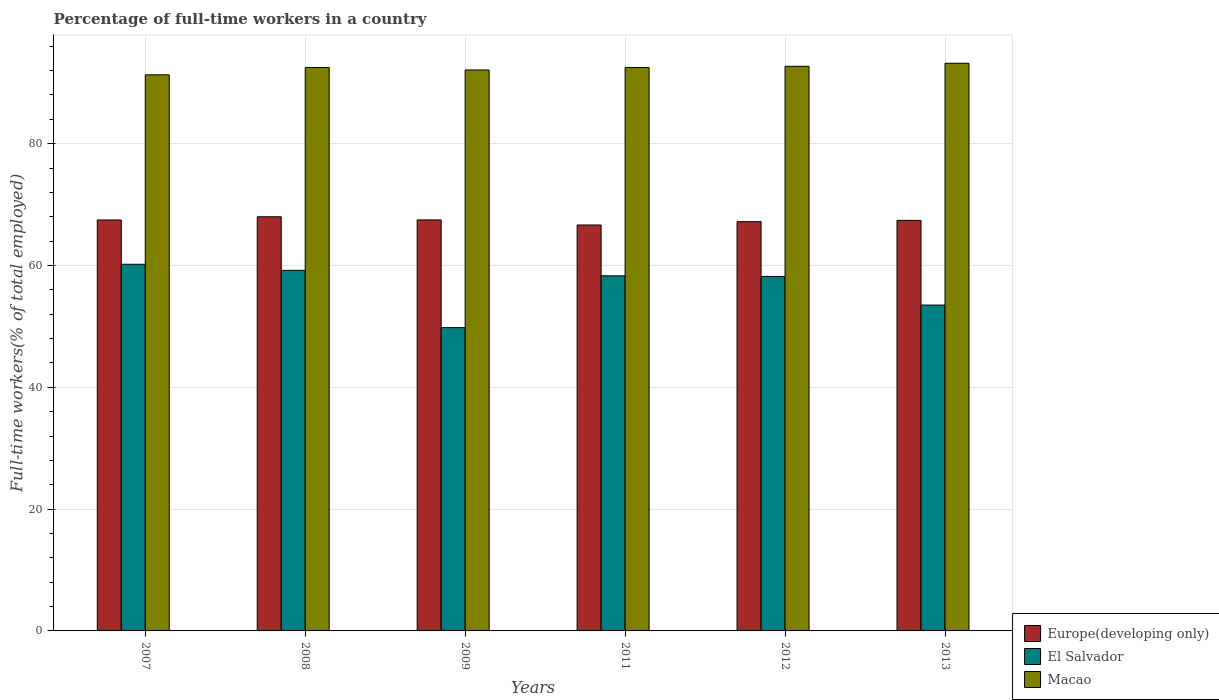How many different coloured bars are there?
Provide a succinct answer. 3. Are the number of bars per tick equal to the number of legend labels?
Ensure brevity in your answer.  Yes. What is the label of the 3rd group of bars from the left?
Give a very brief answer. 2009. What is the percentage of full-time workers in Macao in 2013?
Your answer should be compact. 93.2. Across all years, what is the maximum percentage of full-time workers in Europe(developing only)?
Make the answer very short. 68. Across all years, what is the minimum percentage of full-time workers in Macao?
Provide a succinct answer. 91.3. In which year was the percentage of full-time workers in Macao minimum?
Offer a terse response. 2007. What is the total percentage of full-time workers in El Salvador in the graph?
Make the answer very short. 339.2. What is the difference between the percentage of full-time workers in Europe(developing only) in 2009 and that in 2013?
Give a very brief answer. 0.07. What is the difference between the percentage of full-time workers in Europe(developing only) in 2008 and the percentage of full-time workers in Macao in 2013?
Your answer should be compact. -25.2. What is the average percentage of full-time workers in Macao per year?
Keep it short and to the point. 92.38. In the year 2008, what is the difference between the percentage of full-time workers in Europe(developing only) and percentage of full-time workers in Macao?
Provide a succinct answer. -24.5. In how many years, is the percentage of full-time workers in Macao greater than 56 %?
Offer a very short reply. 6. What is the ratio of the percentage of full-time workers in Macao in 2012 to that in 2013?
Keep it short and to the point. 0.99. Is the percentage of full-time workers in El Salvador in 2008 less than that in 2013?
Provide a short and direct response. No. Is the difference between the percentage of full-time workers in Europe(developing only) in 2007 and 2011 greater than the difference between the percentage of full-time workers in Macao in 2007 and 2011?
Make the answer very short. Yes. What is the difference between the highest and the second highest percentage of full-time workers in Macao?
Provide a succinct answer. 0.5. What is the difference between the highest and the lowest percentage of full-time workers in Macao?
Keep it short and to the point. 1.9. In how many years, is the percentage of full-time workers in El Salvador greater than the average percentage of full-time workers in El Salvador taken over all years?
Provide a succinct answer. 4. Is the sum of the percentage of full-time workers in Europe(developing only) in 2008 and 2011 greater than the maximum percentage of full-time workers in El Salvador across all years?
Your answer should be very brief. Yes. What does the 2nd bar from the left in 2012 represents?
Provide a succinct answer. El Salvador. What does the 3rd bar from the right in 2012 represents?
Provide a short and direct response. Europe(developing only). How many bars are there?
Ensure brevity in your answer.  18. Does the graph contain any zero values?
Provide a short and direct response. No. Does the graph contain grids?
Offer a terse response. Yes. How many legend labels are there?
Provide a succinct answer. 3. What is the title of the graph?
Make the answer very short. Percentage of full-time workers in a country. Does "Arab World" appear as one of the legend labels in the graph?
Keep it short and to the point. No. What is the label or title of the X-axis?
Provide a short and direct response. Years. What is the label or title of the Y-axis?
Make the answer very short. Full-time workers(% of total employed). What is the Full-time workers(% of total employed) of Europe(developing only) in 2007?
Ensure brevity in your answer.  67.47. What is the Full-time workers(% of total employed) of El Salvador in 2007?
Offer a terse response. 60.2. What is the Full-time workers(% of total employed) of Macao in 2007?
Provide a short and direct response. 91.3. What is the Full-time workers(% of total employed) of Europe(developing only) in 2008?
Ensure brevity in your answer.  68. What is the Full-time workers(% of total employed) in El Salvador in 2008?
Offer a very short reply. 59.2. What is the Full-time workers(% of total employed) in Macao in 2008?
Ensure brevity in your answer.  92.5. What is the Full-time workers(% of total employed) of Europe(developing only) in 2009?
Provide a short and direct response. 67.48. What is the Full-time workers(% of total employed) of El Salvador in 2009?
Offer a very short reply. 49.8. What is the Full-time workers(% of total employed) of Macao in 2009?
Your response must be concise. 92.1. What is the Full-time workers(% of total employed) in Europe(developing only) in 2011?
Keep it short and to the point. 66.64. What is the Full-time workers(% of total employed) in El Salvador in 2011?
Offer a very short reply. 58.3. What is the Full-time workers(% of total employed) of Macao in 2011?
Provide a succinct answer. 92.5. What is the Full-time workers(% of total employed) of Europe(developing only) in 2012?
Offer a very short reply. 67.19. What is the Full-time workers(% of total employed) in El Salvador in 2012?
Your answer should be very brief. 58.2. What is the Full-time workers(% of total employed) of Macao in 2012?
Your answer should be compact. 92.7. What is the Full-time workers(% of total employed) of Europe(developing only) in 2013?
Your answer should be very brief. 67.41. What is the Full-time workers(% of total employed) in El Salvador in 2013?
Your answer should be compact. 53.5. What is the Full-time workers(% of total employed) in Macao in 2013?
Provide a succinct answer. 93.2. Across all years, what is the maximum Full-time workers(% of total employed) in Europe(developing only)?
Offer a terse response. 68. Across all years, what is the maximum Full-time workers(% of total employed) in El Salvador?
Your answer should be very brief. 60.2. Across all years, what is the maximum Full-time workers(% of total employed) in Macao?
Keep it short and to the point. 93.2. Across all years, what is the minimum Full-time workers(% of total employed) of Europe(developing only)?
Ensure brevity in your answer.  66.64. Across all years, what is the minimum Full-time workers(% of total employed) in El Salvador?
Provide a short and direct response. 49.8. Across all years, what is the minimum Full-time workers(% of total employed) in Macao?
Keep it short and to the point. 91.3. What is the total Full-time workers(% of total employed) in Europe(developing only) in the graph?
Ensure brevity in your answer.  404.19. What is the total Full-time workers(% of total employed) in El Salvador in the graph?
Keep it short and to the point. 339.2. What is the total Full-time workers(% of total employed) of Macao in the graph?
Offer a terse response. 554.3. What is the difference between the Full-time workers(% of total employed) of Europe(developing only) in 2007 and that in 2008?
Make the answer very short. -0.53. What is the difference between the Full-time workers(% of total employed) in Macao in 2007 and that in 2008?
Your response must be concise. -1.2. What is the difference between the Full-time workers(% of total employed) of Europe(developing only) in 2007 and that in 2009?
Ensure brevity in your answer.  -0.01. What is the difference between the Full-time workers(% of total employed) in El Salvador in 2007 and that in 2009?
Your answer should be compact. 10.4. What is the difference between the Full-time workers(% of total employed) of Europe(developing only) in 2007 and that in 2011?
Provide a succinct answer. 0.83. What is the difference between the Full-time workers(% of total employed) in El Salvador in 2007 and that in 2011?
Make the answer very short. 1.9. What is the difference between the Full-time workers(% of total employed) of Europe(developing only) in 2007 and that in 2012?
Ensure brevity in your answer.  0.28. What is the difference between the Full-time workers(% of total employed) in El Salvador in 2007 and that in 2012?
Provide a short and direct response. 2. What is the difference between the Full-time workers(% of total employed) in Europe(developing only) in 2007 and that in 2013?
Your answer should be very brief. 0.06. What is the difference between the Full-time workers(% of total employed) of Macao in 2007 and that in 2013?
Offer a terse response. -1.9. What is the difference between the Full-time workers(% of total employed) in Europe(developing only) in 2008 and that in 2009?
Your answer should be compact. 0.52. What is the difference between the Full-time workers(% of total employed) in El Salvador in 2008 and that in 2009?
Your response must be concise. 9.4. What is the difference between the Full-time workers(% of total employed) of Europe(developing only) in 2008 and that in 2011?
Your answer should be very brief. 1.35. What is the difference between the Full-time workers(% of total employed) in Macao in 2008 and that in 2011?
Make the answer very short. 0. What is the difference between the Full-time workers(% of total employed) in Europe(developing only) in 2008 and that in 2012?
Offer a very short reply. 0.81. What is the difference between the Full-time workers(% of total employed) in Europe(developing only) in 2008 and that in 2013?
Offer a very short reply. 0.59. What is the difference between the Full-time workers(% of total employed) in El Salvador in 2008 and that in 2013?
Your answer should be very brief. 5.7. What is the difference between the Full-time workers(% of total employed) of Europe(developing only) in 2009 and that in 2011?
Your answer should be very brief. 0.83. What is the difference between the Full-time workers(% of total employed) in Macao in 2009 and that in 2011?
Ensure brevity in your answer.  -0.4. What is the difference between the Full-time workers(% of total employed) in Europe(developing only) in 2009 and that in 2012?
Make the answer very short. 0.29. What is the difference between the Full-time workers(% of total employed) of El Salvador in 2009 and that in 2012?
Your answer should be compact. -8.4. What is the difference between the Full-time workers(% of total employed) of Europe(developing only) in 2009 and that in 2013?
Your response must be concise. 0.07. What is the difference between the Full-time workers(% of total employed) in El Salvador in 2009 and that in 2013?
Provide a succinct answer. -3.7. What is the difference between the Full-time workers(% of total employed) of Europe(developing only) in 2011 and that in 2012?
Offer a very short reply. -0.55. What is the difference between the Full-time workers(% of total employed) in El Salvador in 2011 and that in 2012?
Your answer should be compact. 0.1. What is the difference between the Full-time workers(% of total employed) in Macao in 2011 and that in 2012?
Provide a succinct answer. -0.2. What is the difference between the Full-time workers(% of total employed) of Europe(developing only) in 2011 and that in 2013?
Your answer should be very brief. -0.77. What is the difference between the Full-time workers(% of total employed) in Europe(developing only) in 2012 and that in 2013?
Provide a succinct answer. -0.22. What is the difference between the Full-time workers(% of total employed) of El Salvador in 2012 and that in 2013?
Your answer should be compact. 4.7. What is the difference between the Full-time workers(% of total employed) in Macao in 2012 and that in 2013?
Ensure brevity in your answer.  -0.5. What is the difference between the Full-time workers(% of total employed) in Europe(developing only) in 2007 and the Full-time workers(% of total employed) in El Salvador in 2008?
Offer a very short reply. 8.27. What is the difference between the Full-time workers(% of total employed) in Europe(developing only) in 2007 and the Full-time workers(% of total employed) in Macao in 2008?
Give a very brief answer. -25.03. What is the difference between the Full-time workers(% of total employed) of El Salvador in 2007 and the Full-time workers(% of total employed) of Macao in 2008?
Make the answer very short. -32.3. What is the difference between the Full-time workers(% of total employed) of Europe(developing only) in 2007 and the Full-time workers(% of total employed) of El Salvador in 2009?
Your answer should be very brief. 17.67. What is the difference between the Full-time workers(% of total employed) of Europe(developing only) in 2007 and the Full-time workers(% of total employed) of Macao in 2009?
Your answer should be compact. -24.63. What is the difference between the Full-time workers(% of total employed) in El Salvador in 2007 and the Full-time workers(% of total employed) in Macao in 2009?
Keep it short and to the point. -31.9. What is the difference between the Full-time workers(% of total employed) in Europe(developing only) in 2007 and the Full-time workers(% of total employed) in El Salvador in 2011?
Your answer should be compact. 9.17. What is the difference between the Full-time workers(% of total employed) in Europe(developing only) in 2007 and the Full-time workers(% of total employed) in Macao in 2011?
Offer a very short reply. -25.03. What is the difference between the Full-time workers(% of total employed) in El Salvador in 2007 and the Full-time workers(% of total employed) in Macao in 2011?
Keep it short and to the point. -32.3. What is the difference between the Full-time workers(% of total employed) in Europe(developing only) in 2007 and the Full-time workers(% of total employed) in El Salvador in 2012?
Make the answer very short. 9.27. What is the difference between the Full-time workers(% of total employed) in Europe(developing only) in 2007 and the Full-time workers(% of total employed) in Macao in 2012?
Provide a succinct answer. -25.23. What is the difference between the Full-time workers(% of total employed) in El Salvador in 2007 and the Full-time workers(% of total employed) in Macao in 2012?
Offer a very short reply. -32.5. What is the difference between the Full-time workers(% of total employed) in Europe(developing only) in 2007 and the Full-time workers(% of total employed) in El Salvador in 2013?
Keep it short and to the point. 13.97. What is the difference between the Full-time workers(% of total employed) of Europe(developing only) in 2007 and the Full-time workers(% of total employed) of Macao in 2013?
Keep it short and to the point. -25.73. What is the difference between the Full-time workers(% of total employed) in El Salvador in 2007 and the Full-time workers(% of total employed) in Macao in 2013?
Provide a short and direct response. -33. What is the difference between the Full-time workers(% of total employed) in Europe(developing only) in 2008 and the Full-time workers(% of total employed) in El Salvador in 2009?
Give a very brief answer. 18.2. What is the difference between the Full-time workers(% of total employed) in Europe(developing only) in 2008 and the Full-time workers(% of total employed) in Macao in 2009?
Make the answer very short. -24.1. What is the difference between the Full-time workers(% of total employed) in El Salvador in 2008 and the Full-time workers(% of total employed) in Macao in 2009?
Ensure brevity in your answer.  -32.9. What is the difference between the Full-time workers(% of total employed) of Europe(developing only) in 2008 and the Full-time workers(% of total employed) of El Salvador in 2011?
Ensure brevity in your answer.  9.7. What is the difference between the Full-time workers(% of total employed) of Europe(developing only) in 2008 and the Full-time workers(% of total employed) of Macao in 2011?
Offer a very short reply. -24.5. What is the difference between the Full-time workers(% of total employed) of El Salvador in 2008 and the Full-time workers(% of total employed) of Macao in 2011?
Your response must be concise. -33.3. What is the difference between the Full-time workers(% of total employed) of Europe(developing only) in 2008 and the Full-time workers(% of total employed) of El Salvador in 2012?
Offer a terse response. 9.8. What is the difference between the Full-time workers(% of total employed) in Europe(developing only) in 2008 and the Full-time workers(% of total employed) in Macao in 2012?
Your response must be concise. -24.7. What is the difference between the Full-time workers(% of total employed) of El Salvador in 2008 and the Full-time workers(% of total employed) of Macao in 2012?
Give a very brief answer. -33.5. What is the difference between the Full-time workers(% of total employed) of Europe(developing only) in 2008 and the Full-time workers(% of total employed) of El Salvador in 2013?
Your response must be concise. 14.5. What is the difference between the Full-time workers(% of total employed) of Europe(developing only) in 2008 and the Full-time workers(% of total employed) of Macao in 2013?
Your response must be concise. -25.2. What is the difference between the Full-time workers(% of total employed) of El Salvador in 2008 and the Full-time workers(% of total employed) of Macao in 2013?
Offer a terse response. -34. What is the difference between the Full-time workers(% of total employed) in Europe(developing only) in 2009 and the Full-time workers(% of total employed) in El Salvador in 2011?
Give a very brief answer. 9.18. What is the difference between the Full-time workers(% of total employed) in Europe(developing only) in 2009 and the Full-time workers(% of total employed) in Macao in 2011?
Keep it short and to the point. -25.02. What is the difference between the Full-time workers(% of total employed) in El Salvador in 2009 and the Full-time workers(% of total employed) in Macao in 2011?
Offer a very short reply. -42.7. What is the difference between the Full-time workers(% of total employed) of Europe(developing only) in 2009 and the Full-time workers(% of total employed) of El Salvador in 2012?
Offer a terse response. 9.28. What is the difference between the Full-time workers(% of total employed) in Europe(developing only) in 2009 and the Full-time workers(% of total employed) in Macao in 2012?
Provide a succinct answer. -25.22. What is the difference between the Full-time workers(% of total employed) in El Salvador in 2009 and the Full-time workers(% of total employed) in Macao in 2012?
Your answer should be very brief. -42.9. What is the difference between the Full-time workers(% of total employed) in Europe(developing only) in 2009 and the Full-time workers(% of total employed) in El Salvador in 2013?
Offer a terse response. 13.98. What is the difference between the Full-time workers(% of total employed) of Europe(developing only) in 2009 and the Full-time workers(% of total employed) of Macao in 2013?
Provide a succinct answer. -25.72. What is the difference between the Full-time workers(% of total employed) in El Salvador in 2009 and the Full-time workers(% of total employed) in Macao in 2013?
Provide a succinct answer. -43.4. What is the difference between the Full-time workers(% of total employed) in Europe(developing only) in 2011 and the Full-time workers(% of total employed) in El Salvador in 2012?
Your answer should be very brief. 8.44. What is the difference between the Full-time workers(% of total employed) of Europe(developing only) in 2011 and the Full-time workers(% of total employed) of Macao in 2012?
Keep it short and to the point. -26.06. What is the difference between the Full-time workers(% of total employed) of El Salvador in 2011 and the Full-time workers(% of total employed) of Macao in 2012?
Provide a succinct answer. -34.4. What is the difference between the Full-time workers(% of total employed) of Europe(developing only) in 2011 and the Full-time workers(% of total employed) of El Salvador in 2013?
Offer a terse response. 13.14. What is the difference between the Full-time workers(% of total employed) of Europe(developing only) in 2011 and the Full-time workers(% of total employed) of Macao in 2013?
Give a very brief answer. -26.56. What is the difference between the Full-time workers(% of total employed) of El Salvador in 2011 and the Full-time workers(% of total employed) of Macao in 2013?
Your answer should be very brief. -34.9. What is the difference between the Full-time workers(% of total employed) in Europe(developing only) in 2012 and the Full-time workers(% of total employed) in El Salvador in 2013?
Provide a succinct answer. 13.69. What is the difference between the Full-time workers(% of total employed) in Europe(developing only) in 2012 and the Full-time workers(% of total employed) in Macao in 2013?
Make the answer very short. -26.01. What is the difference between the Full-time workers(% of total employed) of El Salvador in 2012 and the Full-time workers(% of total employed) of Macao in 2013?
Keep it short and to the point. -35. What is the average Full-time workers(% of total employed) of Europe(developing only) per year?
Offer a very short reply. 67.36. What is the average Full-time workers(% of total employed) in El Salvador per year?
Offer a very short reply. 56.53. What is the average Full-time workers(% of total employed) of Macao per year?
Provide a short and direct response. 92.38. In the year 2007, what is the difference between the Full-time workers(% of total employed) of Europe(developing only) and Full-time workers(% of total employed) of El Salvador?
Provide a succinct answer. 7.27. In the year 2007, what is the difference between the Full-time workers(% of total employed) of Europe(developing only) and Full-time workers(% of total employed) of Macao?
Give a very brief answer. -23.83. In the year 2007, what is the difference between the Full-time workers(% of total employed) of El Salvador and Full-time workers(% of total employed) of Macao?
Your answer should be compact. -31.1. In the year 2008, what is the difference between the Full-time workers(% of total employed) of Europe(developing only) and Full-time workers(% of total employed) of El Salvador?
Provide a short and direct response. 8.8. In the year 2008, what is the difference between the Full-time workers(% of total employed) in Europe(developing only) and Full-time workers(% of total employed) in Macao?
Your response must be concise. -24.5. In the year 2008, what is the difference between the Full-time workers(% of total employed) of El Salvador and Full-time workers(% of total employed) of Macao?
Make the answer very short. -33.3. In the year 2009, what is the difference between the Full-time workers(% of total employed) of Europe(developing only) and Full-time workers(% of total employed) of El Salvador?
Your answer should be compact. 17.68. In the year 2009, what is the difference between the Full-time workers(% of total employed) of Europe(developing only) and Full-time workers(% of total employed) of Macao?
Give a very brief answer. -24.62. In the year 2009, what is the difference between the Full-time workers(% of total employed) of El Salvador and Full-time workers(% of total employed) of Macao?
Provide a succinct answer. -42.3. In the year 2011, what is the difference between the Full-time workers(% of total employed) in Europe(developing only) and Full-time workers(% of total employed) in El Salvador?
Keep it short and to the point. 8.34. In the year 2011, what is the difference between the Full-time workers(% of total employed) of Europe(developing only) and Full-time workers(% of total employed) of Macao?
Offer a terse response. -25.86. In the year 2011, what is the difference between the Full-time workers(% of total employed) in El Salvador and Full-time workers(% of total employed) in Macao?
Offer a very short reply. -34.2. In the year 2012, what is the difference between the Full-time workers(% of total employed) in Europe(developing only) and Full-time workers(% of total employed) in El Salvador?
Provide a short and direct response. 8.99. In the year 2012, what is the difference between the Full-time workers(% of total employed) of Europe(developing only) and Full-time workers(% of total employed) of Macao?
Your response must be concise. -25.51. In the year 2012, what is the difference between the Full-time workers(% of total employed) in El Salvador and Full-time workers(% of total employed) in Macao?
Provide a short and direct response. -34.5. In the year 2013, what is the difference between the Full-time workers(% of total employed) of Europe(developing only) and Full-time workers(% of total employed) of El Salvador?
Keep it short and to the point. 13.91. In the year 2013, what is the difference between the Full-time workers(% of total employed) of Europe(developing only) and Full-time workers(% of total employed) of Macao?
Provide a succinct answer. -25.79. In the year 2013, what is the difference between the Full-time workers(% of total employed) in El Salvador and Full-time workers(% of total employed) in Macao?
Your response must be concise. -39.7. What is the ratio of the Full-time workers(% of total employed) of Europe(developing only) in 2007 to that in 2008?
Your response must be concise. 0.99. What is the ratio of the Full-time workers(% of total employed) in El Salvador in 2007 to that in 2008?
Ensure brevity in your answer.  1.02. What is the ratio of the Full-time workers(% of total employed) in El Salvador in 2007 to that in 2009?
Your answer should be compact. 1.21. What is the ratio of the Full-time workers(% of total employed) in Europe(developing only) in 2007 to that in 2011?
Your answer should be compact. 1.01. What is the ratio of the Full-time workers(% of total employed) of El Salvador in 2007 to that in 2011?
Provide a succinct answer. 1.03. What is the ratio of the Full-time workers(% of total employed) of El Salvador in 2007 to that in 2012?
Make the answer very short. 1.03. What is the ratio of the Full-time workers(% of total employed) in Macao in 2007 to that in 2012?
Offer a terse response. 0.98. What is the ratio of the Full-time workers(% of total employed) of Europe(developing only) in 2007 to that in 2013?
Keep it short and to the point. 1. What is the ratio of the Full-time workers(% of total employed) of El Salvador in 2007 to that in 2013?
Give a very brief answer. 1.13. What is the ratio of the Full-time workers(% of total employed) in Macao in 2007 to that in 2013?
Offer a very short reply. 0.98. What is the ratio of the Full-time workers(% of total employed) in Europe(developing only) in 2008 to that in 2009?
Offer a very short reply. 1.01. What is the ratio of the Full-time workers(% of total employed) of El Salvador in 2008 to that in 2009?
Keep it short and to the point. 1.19. What is the ratio of the Full-time workers(% of total employed) in Macao in 2008 to that in 2009?
Offer a very short reply. 1. What is the ratio of the Full-time workers(% of total employed) in Europe(developing only) in 2008 to that in 2011?
Give a very brief answer. 1.02. What is the ratio of the Full-time workers(% of total employed) of El Salvador in 2008 to that in 2011?
Give a very brief answer. 1.02. What is the ratio of the Full-time workers(% of total employed) of Europe(developing only) in 2008 to that in 2012?
Your answer should be very brief. 1.01. What is the ratio of the Full-time workers(% of total employed) in El Salvador in 2008 to that in 2012?
Make the answer very short. 1.02. What is the ratio of the Full-time workers(% of total employed) in Macao in 2008 to that in 2012?
Make the answer very short. 1. What is the ratio of the Full-time workers(% of total employed) in Europe(developing only) in 2008 to that in 2013?
Your response must be concise. 1.01. What is the ratio of the Full-time workers(% of total employed) of El Salvador in 2008 to that in 2013?
Offer a very short reply. 1.11. What is the ratio of the Full-time workers(% of total employed) in Macao in 2008 to that in 2013?
Give a very brief answer. 0.99. What is the ratio of the Full-time workers(% of total employed) of Europe(developing only) in 2009 to that in 2011?
Your answer should be very brief. 1.01. What is the ratio of the Full-time workers(% of total employed) in El Salvador in 2009 to that in 2011?
Offer a very short reply. 0.85. What is the ratio of the Full-time workers(% of total employed) in Europe(developing only) in 2009 to that in 2012?
Offer a terse response. 1. What is the ratio of the Full-time workers(% of total employed) of El Salvador in 2009 to that in 2012?
Offer a very short reply. 0.86. What is the ratio of the Full-time workers(% of total employed) of Macao in 2009 to that in 2012?
Your answer should be compact. 0.99. What is the ratio of the Full-time workers(% of total employed) of Europe(developing only) in 2009 to that in 2013?
Ensure brevity in your answer.  1. What is the ratio of the Full-time workers(% of total employed) of El Salvador in 2009 to that in 2013?
Keep it short and to the point. 0.93. What is the ratio of the Full-time workers(% of total employed) of Macao in 2009 to that in 2013?
Give a very brief answer. 0.99. What is the ratio of the Full-time workers(% of total employed) in Europe(developing only) in 2011 to that in 2012?
Keep it short and to the point. 0.99. What is the ratio of the Full-time workers(% of total employed) in El Salvador in 2011 to that in 2012?
Offer a very short reply. 1. What is the ratio of the Full-time workers(% of total employed) of Macao in 2011 to that in 2012?
Keep it short and to the point. 1. What is the ratio of the Full-time workers(% of total employed) in El Salvador in 2011 to that in 2013?
Provide a short and direct response. 1.09. What is the ratio of the Full-time workers(% of total employed) in Macao in 2011 to that in 2013?
Offer a very short reply. 0.99. What is the ratio of the Full-time workers(% of total employed) in El Salvador in 2012 to that in 2013?
Your response must be concise. 1.09. What is the ratio of the Full-time workers(% of total employed) of Macao in 2012 to that in 2013?
Ensure brevity in your answer.  0.99. What is the difference between the highest and the second highest Full-time workers(% of total employed) in Europe(developing only)?
Provide a succinct answer. 0.52. What is the difference between the highest and the second highest Full-time workers(% of total employed) in El Salvador?
Your answer should be very brief. 1. What is the difference between the highest and the second highest Full-time workers(% of total employed) in Macao?
Provide a short and direct response. 0.5. What is the difference between the highest and the lowest Full-time workers(% of total employed) in Europe(developing only)?
Keep it short and to the point. 1.35. 